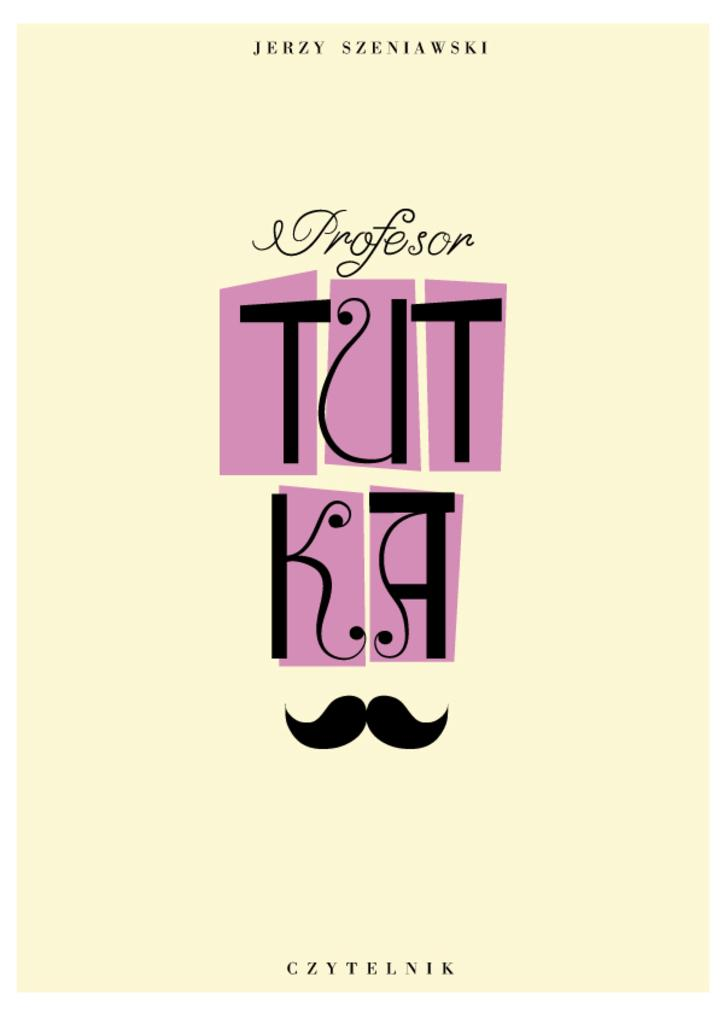What is present on the poster in the image? There is a poster in the image, and it has text on it. Can you describe the text on the poster? Unfortunately, the specific text on the poster cannot be determined from the given facts. Is there any other element on the poster besides the text? The provided facts do not mention any other elements on the poster. What type of creature is depicted on the vegetable in the image? There is no creature or vegetable present in the image; it only features a poster with text on it. 